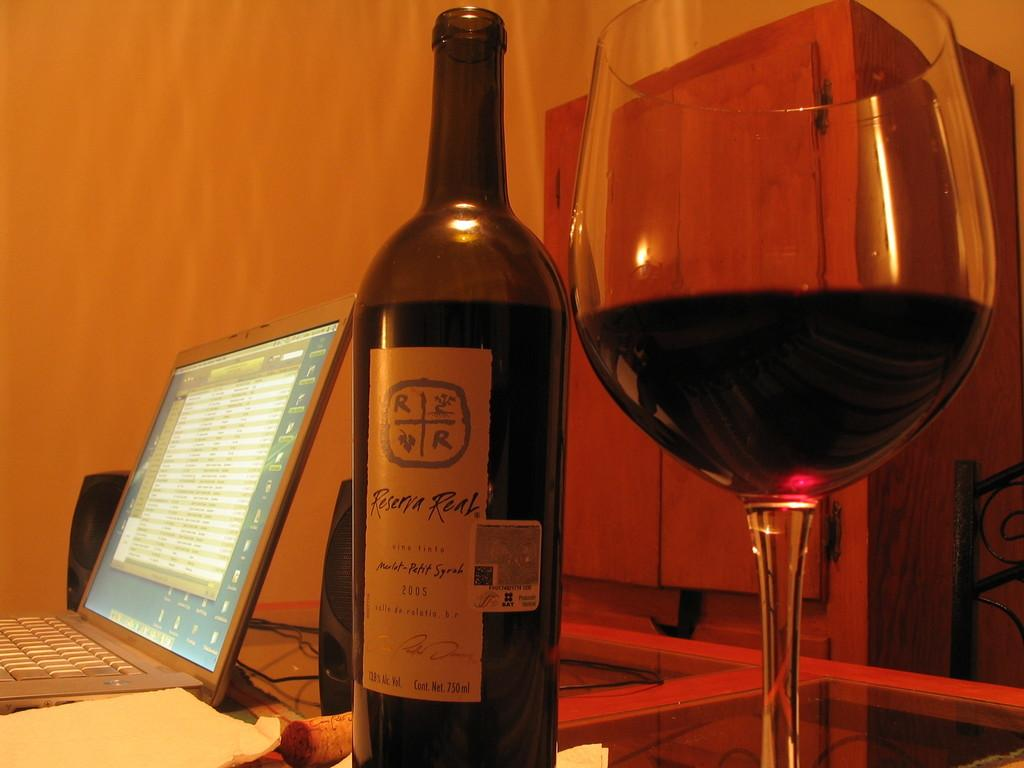<image>
Create a compact narrative representing the image presented. A bottle of Reserva Real sits on a glass table next to a half full glass. 